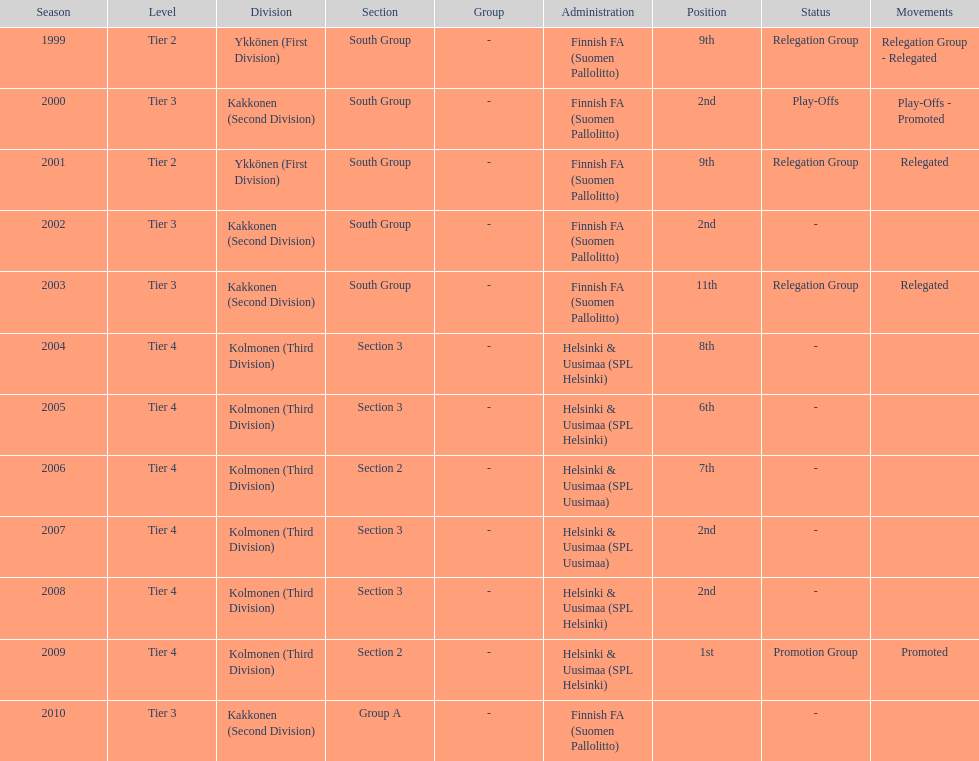How many tiers had more than one relegated movement? 1. 